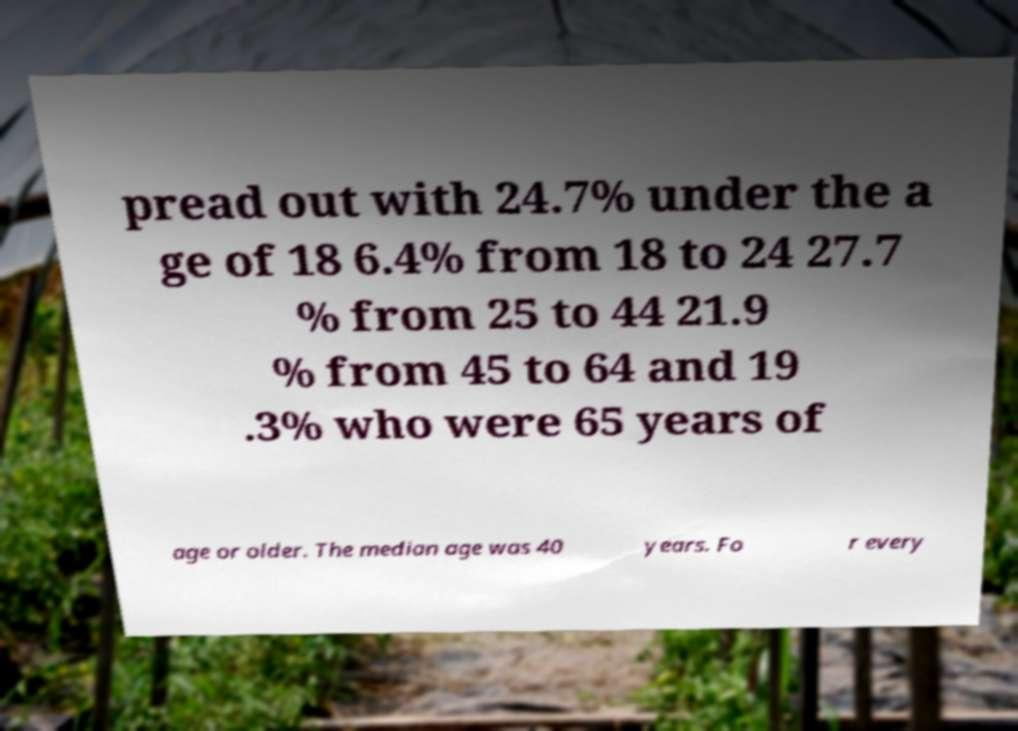Can you read and provide the text displayed in the image?This photo seems to have some interesting text. Can you extract and type it out for me? pread out with 24.7% under the a ge of 18 6.4% from 18 to 24 27.7 % from 25 to 44 21.9 % from 45 to 64 and 19 .3% who were 65 years of age or older. The median age was 40 years. Fo r every 